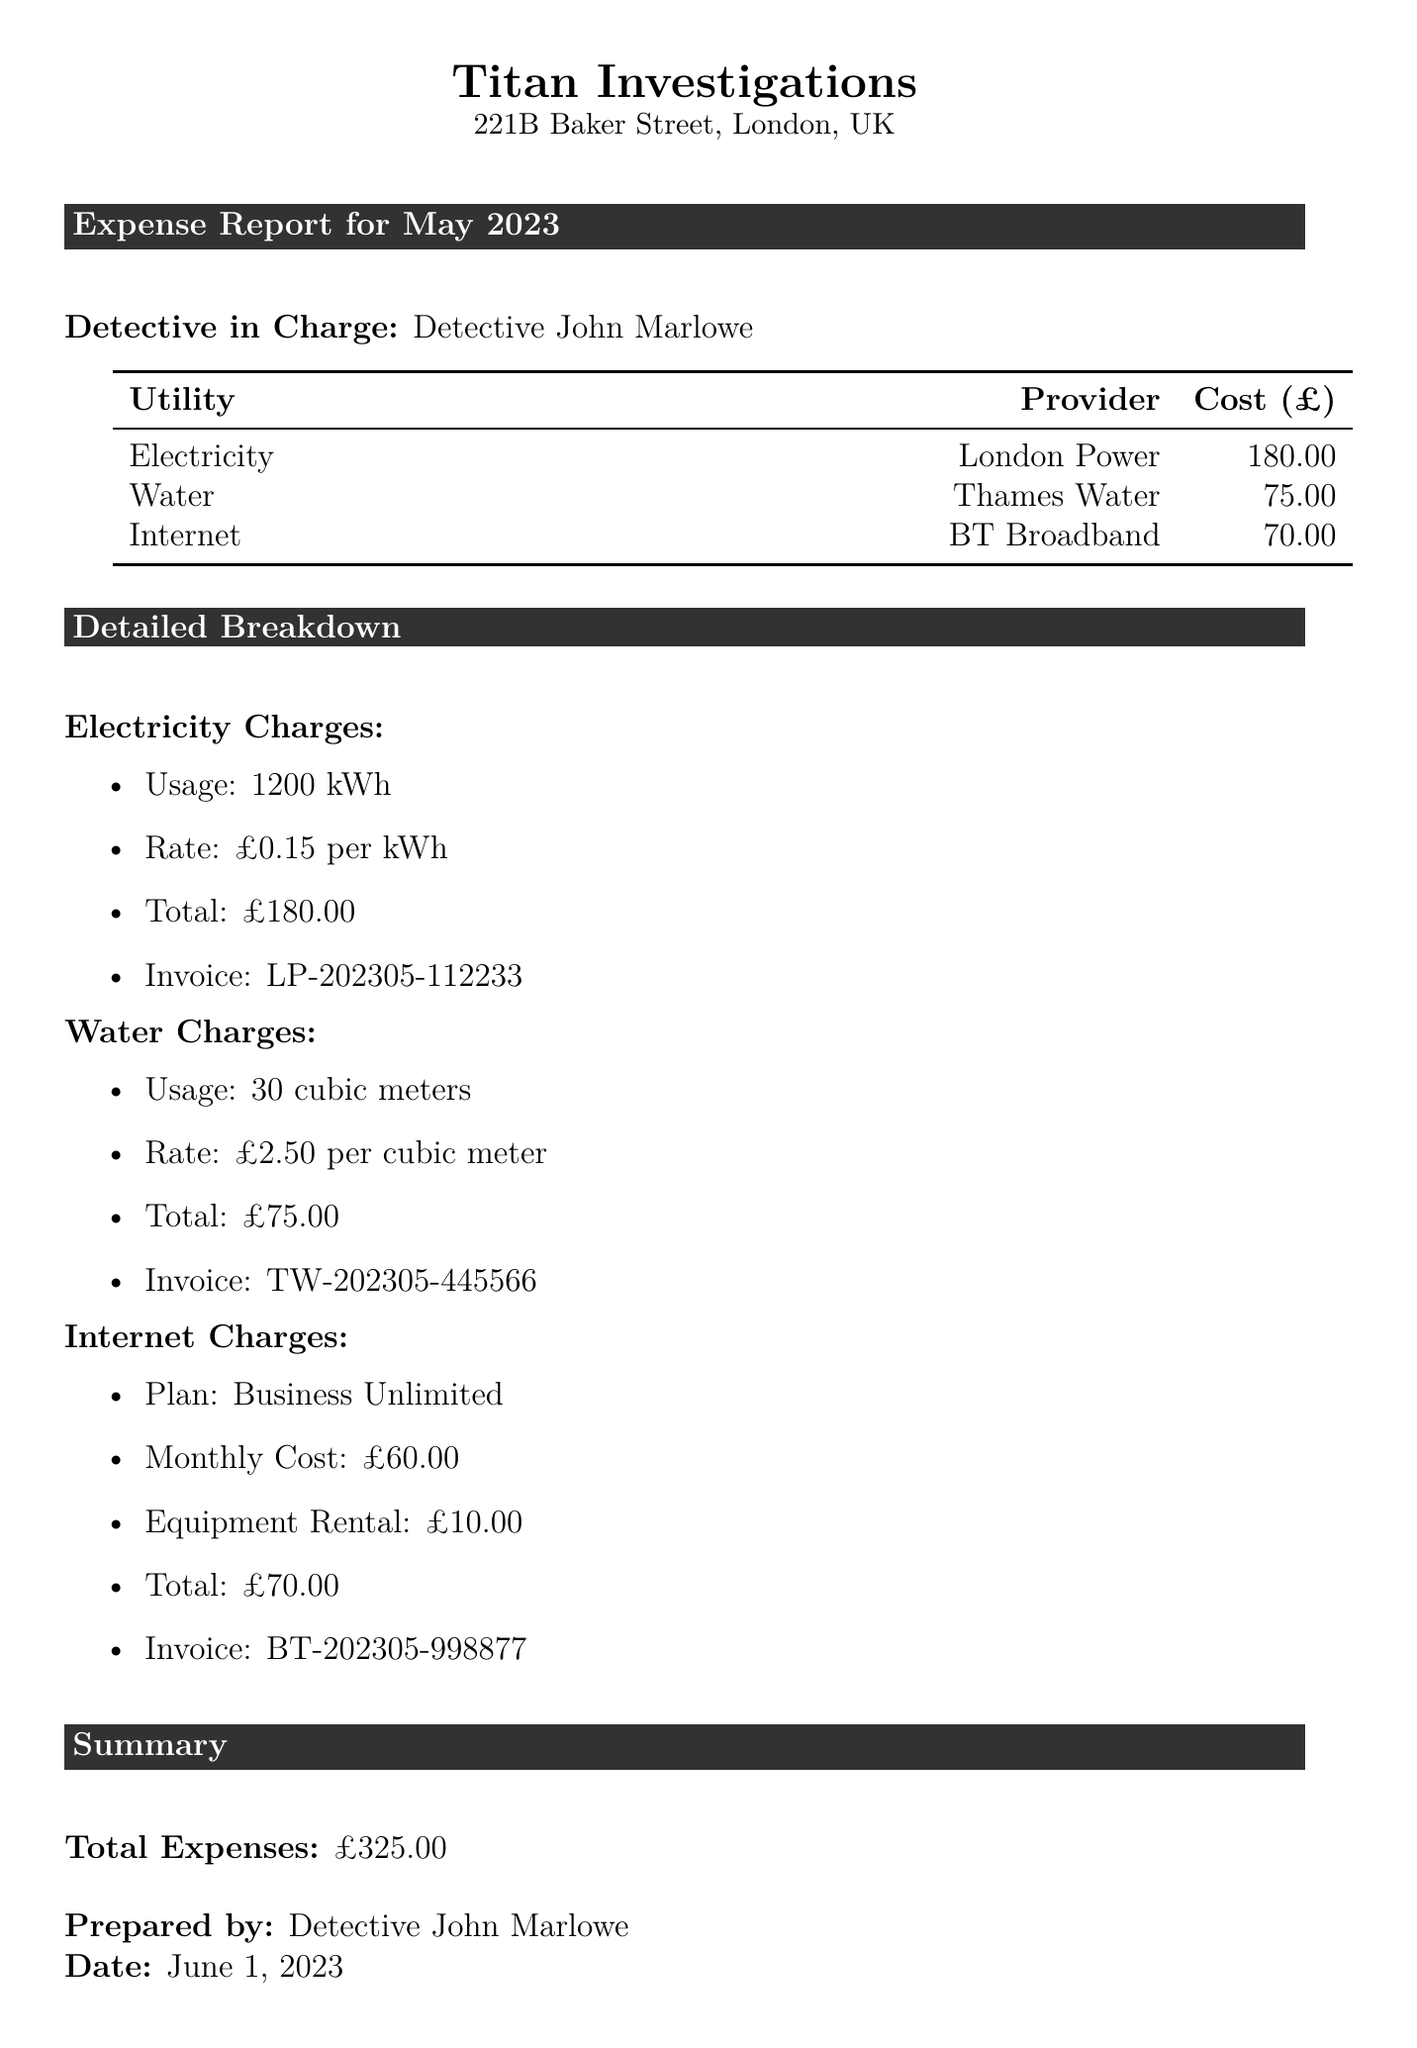What is the total cost of electricity? The total cost of electricity is specifically stated in the document under Electricity Charges, which is £180.00.
Answer: £180.00 Who is the provider of the water service? The provider of the water service is listed in the table under Water, identified as Thames Water.
Answer: Thames Water How many cubic meters of water were used? The document specifies the usage of water, indicating it was 30 cubic meters as per the Water Charges section.
Answer: 30 cubic meters What is the invoice number for the internet charges? The invoice number for the internet charges is provided under Internet Charges, specifically BT-202305-998877.
Answer: BT-202305-998877 What type of plan is selected for internet service? The type of plan for the internet service is stated clearly in the Internet Charges section, as Business Unlimited.
Answer: Business Unlimited What is the total expense for May 2023? The total expenses for May 2023 are summarized in the Summary section, which totals £325.00.
Answer: £325.00 What is the rate per kWh for electricity? The rate per kWh for electricity is mentioned in the breakdown, which is £0.15 per kWh.
Answer: £0.15 per kWh How much is charged for equipment rental in the internet charges? The equipment rental cost is specifically listed in the Internet Charges, which is £10.00.
Answer: £10.00 Who prepared the expense report? The report specifies the preparer as Detective John Marlowe in the Summary section.
Answer: Detective John Marlowe 